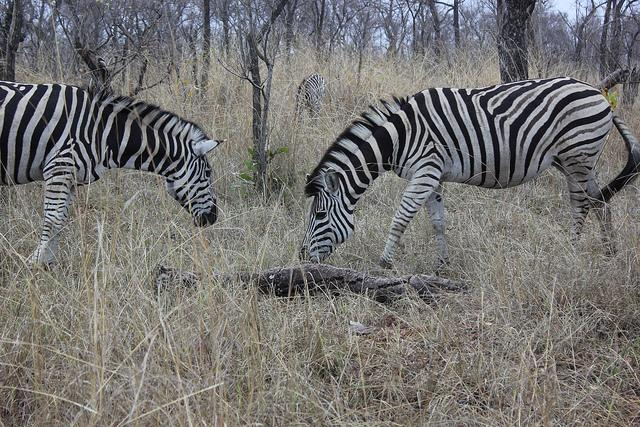What matches the color scheme of the animals? black white 